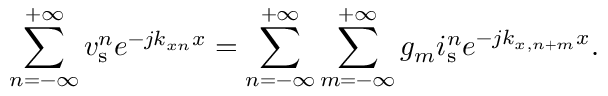Convert formula to latex. <formula><loc_0><loc_0><loc_500><loc_500>\sum _ { n = - \infty } ^ { + \infty } v _ { s } ^ { n } e ^ { - j k _ { x n } x } = \sum _ { n = - \infty } ^ { + \infty } \sum _ { m = - \infty } ^ { + \infty } g _ { m } i _ { s } ^ { n } e ^ { - j k _ { x , n + m } x } .</formula> 